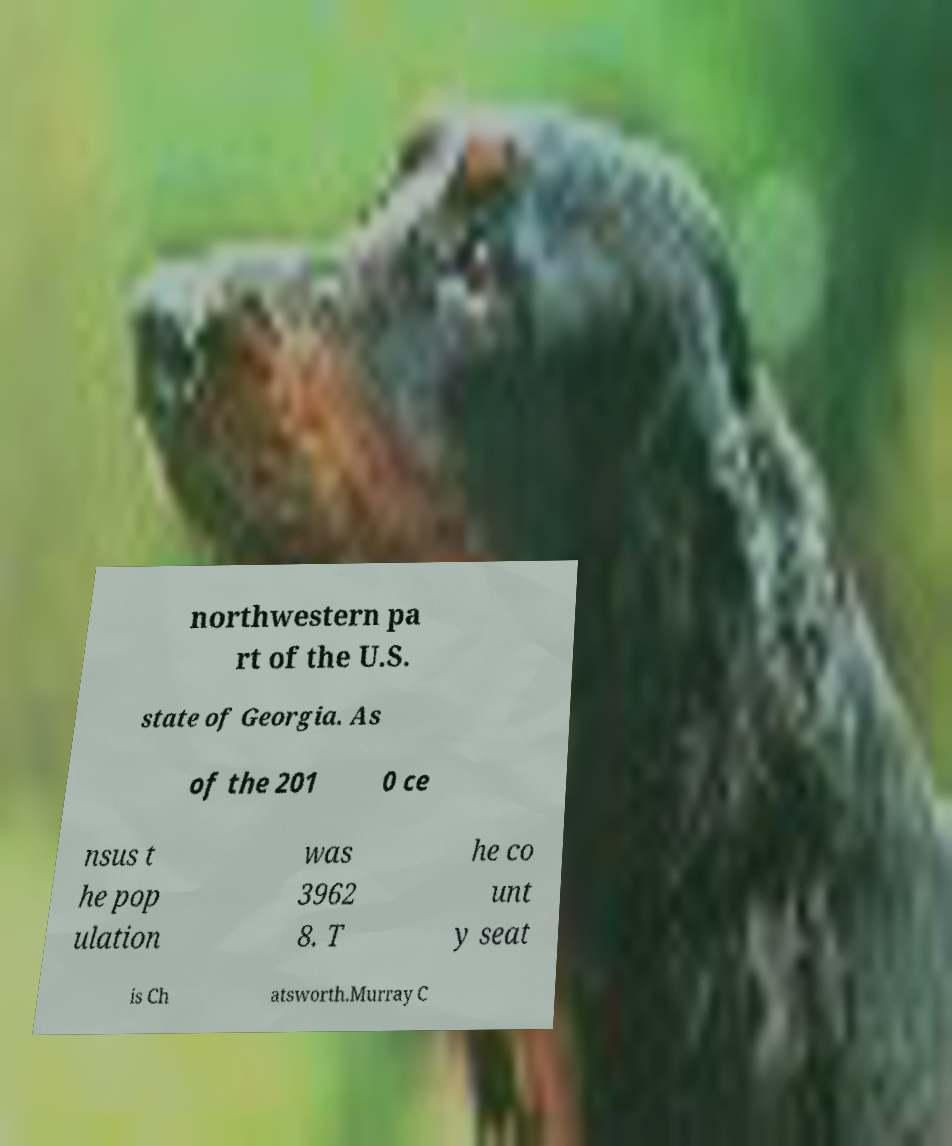What messages or text are displayed in this image? I need them in a readable, typed format. northwestern pa rt of the U.S. state of Georgia. As of the 201 0 ce nsus t he pop ulation was 3962 8. T he co unt y seat is Ch atsworth.Murray C 